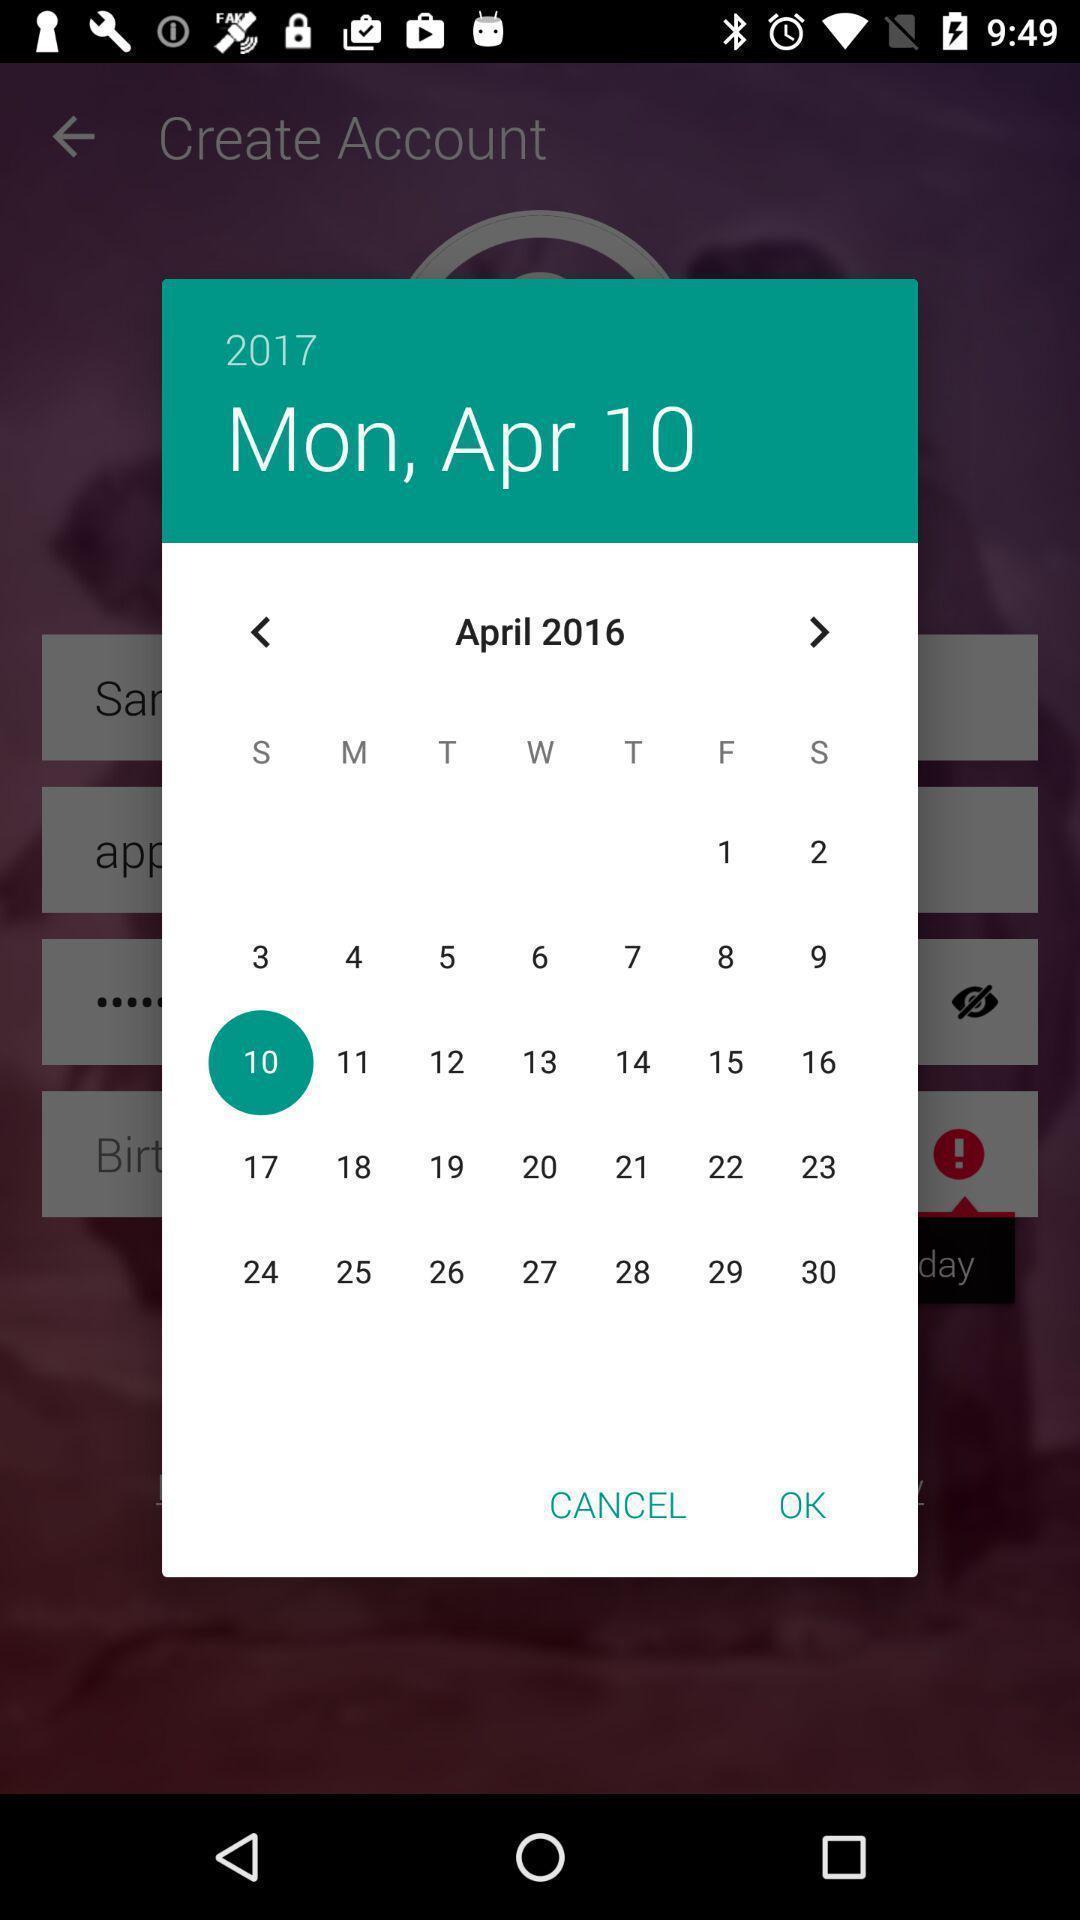Describe the content in this image. Pop-up of a calendar on app. 